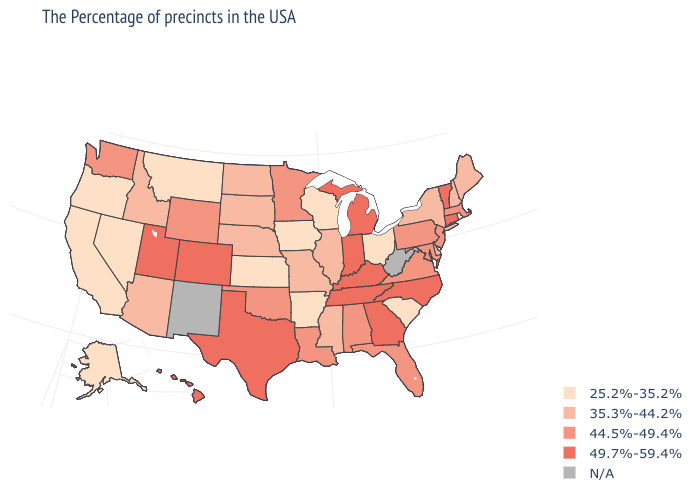What is the lowest value in states that border Pennsylvania?
Short answer required. 25.2%-35.2%. Which states have the highest value in the USA?
Short answer required. Vermont, Connecticut, North Carolina, Georgia, Michigan, Kentucky, Indiana, Tennessee, Texas, Colorado, Utah, Hawaii. Does the map have missing data?
Write a very short answer. Yes. Among the states that border Wisconsin , which have the highest value?
Short answer required. Michigan. What is the value of Montana?
Answer briefly. 25.2%-35.2%. What is the highest value in states that border Utah?
Quick response, please. 49.7%-59.4%. Does Vermont have the highest value in the USA?
Keep it brief. Yes. Name the states that have a value in the range 35.3%-44.2%?
Give a very brief answer. Maine, New Hampshire, New York, Delaware, Illinois, Mississippi, Missouri, Nebraska, South Dakota, North Dakota, Arizona, Idaho. What is the value of Delaware?
Answer briefly. 35.3%-44.2%. What is the value of Montana?
Give a very brief answer. 25.2%-35.2%. Name the states that have a value in the range 35.3%-44.2%?
Quick response, please. Maine, New Hampshire, New York, Delaware, Illinois, Mississippi, Missouri, Nebraska, South Dakota, North Dakota, Arizona, Idaho. Name the states that have a value in the range N/A?
Short answer required. West Virginia, New Mexico. Name the states that have a value in the range 44.5%-49.4%?
Concise answer only. Massachusetts, New Jersey, Maryland, Pennsylvania, Virginia, Florida, Alabama, Louisiana, Minnesota, Oklahoma, Wyoming, Washington. How many symbols are there in the legend?
Give a very brief answer. 5. What is the value of Connecticut?
Answer briefly. 49.7%-59.4%. 